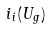<formula> <loc_0><loc_0><loc_500><loc_500>i _ { i } ( U _ { g } )</formula> 